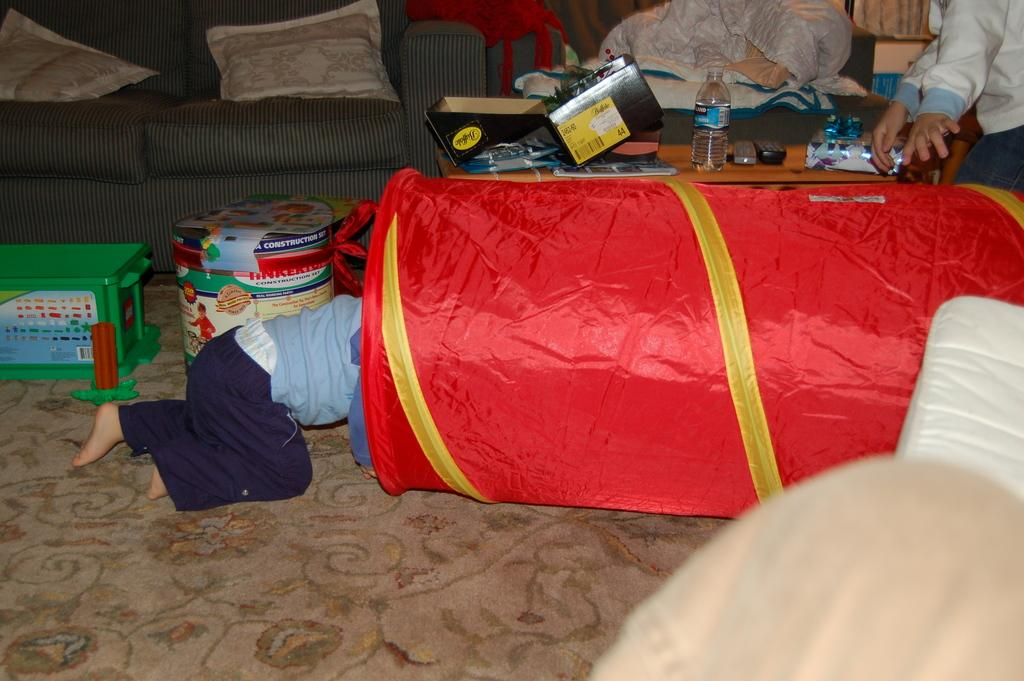Who or what can be seen in the image? There are people in the image. What is located on the left side of the image? There are toys and a box on the left side of the image. What type of furniture is present in the image? There is a sofa in the image. What items can be found on the table in the image? There is a bottle, boxes, remotes, and other things on the table in the image. How many rabbits can be seen playing in the field in the image? There are no rabbits or fields present in the image. 